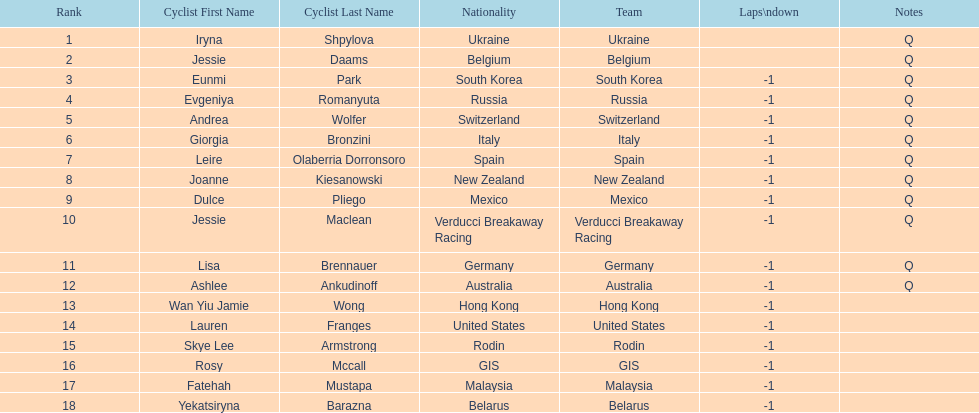What two cyclists come from teams with no laps down? Iryna Shpylova, Jessie Daams. 